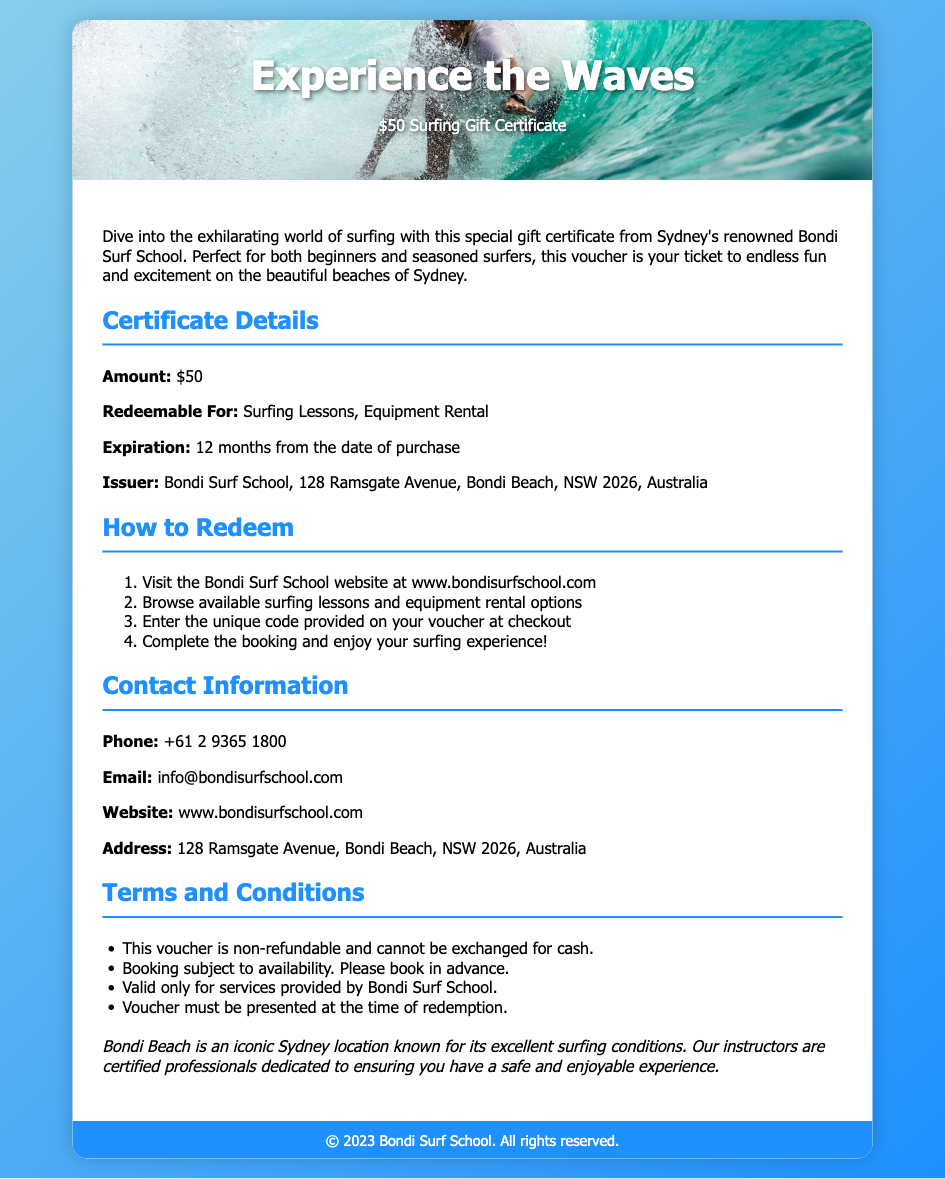What is the amount of the gift certificate? The amount specified for the gift certificate in the document is $50.
Answer: $50 What is the issuer of the gift certificate? The issuer of the gift certificate is stated to be Bondi Surf School.
Answer: Bondi Surf School Where is the Bondi Surf School located? The location mentioned in the document is 128 Ramsgate Avenue, Bondi Beach, NSW 2026, Australia.
Answer: 128 Ramsgate Avenue, Bondi Beach, NSW 2026, Australia What can the gift certificate be redeemed for? The gift certificate can be redeemed for Surfing Lessons and Equipment Rental as specified in the document.
Answer: Surfing Lessons, Equipment Rental What is the expiration period of the gift certificate? The document states that the gift certificate expires 12 months from the date of purchase.
Answer: 12 months How do you redeem the certificate? The instructions in the document detail that you need to visit the Bondi Surf School website and enter a unique code at checkout to redeem the certificate.
Answer: Visit the website and enter the unique code What should you do if you encounter unavailability? The document mentions that the booking is subject to availability; hence, you should book in advance to ensure you can redeem the certificate.
Answer: Book in advance What type of certificate is this document for? The document is specifically a gift certificate, as the title and content imply.
Answer: Gift certificate What is a term mentioned regarding voucher refunds? It is stated in the terms and conditions that the voucher is non-refundable and cannot be exchanged for cash.
Answer: Non-refundable 